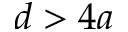<formula> <loc_0><loc_0><loc_500><loc_500>d > 4 a</formula> 